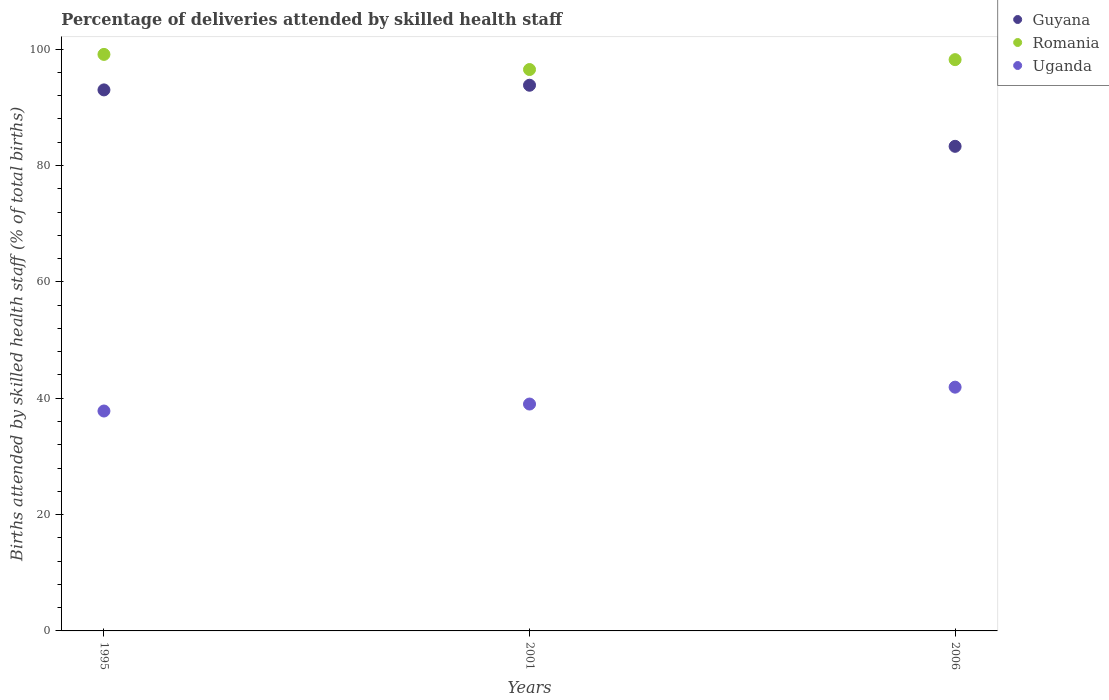How many different coloured dotlines are there?
Your answer should be very brief. 3. Across all years, what is the maximum percentage of births attended by skilled health staff in Guyana?
Ensure brevity in your answer.  93.8. Across all years, what is the minimum percentage of births attended by skilled health staff in Romania?
Keep it short and to the point. 96.5. What is the total percentage of births attended by skilled health staff in Guyana in the graph?
Your answer should be very brief. 270.1. What is the difference between the percentage of births attended by skilled health staff in Romania in 2001 and that in 2006?
Your answer should be compact. -1.7. What is the difference between the percentage of births attended by skilled health staff in Romania in 1995 and the percentage of births attended by skilled health staff in Guyana in 2001?
Offer a very short reply. 5.3. What is the average percentage of births attended by skilled health staff in Uganda per year?
Ensure brevity in your answer.  39.57. In the year 1995, what is the difference between the percentage of births attended by skilled health staff in Romania and percentage of births attended by skilled health staff in Guyana?
Your answer should be very brief. 6.1. In how many years, is the percentage of births attended by skilled health staff in Romania greater than 16 %?
Offer a very short reply. 3. What is the ratio of the percentage of births attended by skilled health staff in Romania in 1995 to that in 2001?
Keep it short and to the point. 1.03. Is the percentage of births attended by skilled health staff in Romania in 1995 less than that in 2001?
Provide a succinct answer. No. What is the difference between the highest and the second highest percentage of births attended by skilled health staff in Guyana?
Your response must be concise. 0.8. In how many years, is the percentage of births attended by skilled health staff in Guyana greater than the average percentage of births attended by skilled health staff in Guyana taken over all years?
Your answer should be compact. 2. Is the sum of the percentage of births attended by skilled health staff in Romania in 1995 and 2001 greater than the maximum percentage of births attended by skilled health staff in Uganda across all years?
Your answer should be compact. Yes. Does the percentage of births attended by skilled health staff in Romania monotonically increase over the years?
Give a very brief answer. No. How many dotlines are there?
Make the answer very short. 3. Are the values on the major ticks of Y-axis written in scientific E-notation?
Give a very brief answer. No. Does the graph contain any zero values?
Provide a short and direct response. No. Does the graph contain grids?
Provide a succinct answer. No. Where does the legend appear in the graph?
Your answer should be compact. Top right. How many legend labels are there?
Give a very brief answer. 3. What is the title of the graph?
Make the answer very short. Percentage of deliveries attended by skilled health staff. What is the label or title of the X-axis?
Keep it short and to the point. Years. What is the label or title of the Y-axis?
Make the answer very short. Births attended by skilled health staff (% of total births). What is the Births attended by skilled health staff (% of total births) of Guyana in 1995?
Give a very brief answer. 93. What is the Births attended by skilled health staff (% of total births) of Romania in 1995?
Your answer should be compact. 99.1. What is the Births attended by skilled health staff (% of total births) of Uganda in 1995?
Provide a short and direct response. 37.8. What is the Births attended by skilled health staff (% of total births) in Guyana in 2001?
Make the answer very short. 93.8. What is the Births attended by skilled health staff (% of total births) in Romania in 2001?
Provide a succinct answer. 96.5. What is the Births attended by skilled health staff (% of total births) in Uganda in 2001?
Offer a terse response. 39. What is the Births attended by skilled health staff (% of total births) in Guyana in 2006?
Offer a very short reply. 83.3. What is the Births attended by skilled health staff (% of total births) of Romania in 2006?
Keep it short and to the point. 98.2. What is the Births attended by skilled health staff (% of total births) of Uganda in 2006?
Offer a terse response. 41.9. Across all years, what is the maximum Births attended by skilled health staff (% of total births) of Guyana?
Provide a short and direct response. 93.8. Across all years, what is the maximum Births attended by skilled health staff (% of total births) of Romania?
Make the answer very short. 99.1. Across all years, what is the maximum Births attended by skilled health staff (% of total births) in Uganda?
Your answer should be very brief. 41.9. Across all years, what is the minimum Births attended by skilled health staff (% of total births) in Guyana?
Offer a terse response. 83.3. Across all years, what is the minimum Births attended by skilled health staff (% of total births) of Romania?
Provide a succinct answer. 96.5. Across all years, what is the minimum Births attended by skilled health staff (% of total births) in Uganda?
Offer a terse response. 37.8. What is the total Births attended by skilled health staff (% of total births) of Guyana in the graph?
Keep it short and to the point. 270.1. What is the total Births attended by skilled health staff (% of total births) in Romania in the graph?
Your answer should be compact. 293.8. What is the total Births attended by skilled health staff (% of total births) in Uganda in the graph?
Offer a terse response. 118.7. What is the difference between the Births attended by skilled health staff (% of total births) in Guyana in 1995 and that in 2001?
Offer a very short reply. -0.8. What is the difference between the Births attended by skilled health staff (% of total births) in Romania in 1995 and that in 2001?
Offer a terse response. 2.6. What is the difference between the Births attended by skilled health staff (% of total births) of Uganda in 1995 and that in 2001?
Provide a succinct answer. -1.2. What is the difference between the Births attended by skilled health staff (% of total births) of Romania in 1995 and that in 2006?
Provide a short and direct response. 0.9. What is the difference between the Births attended by skilled health staff (% of total births) of Uganda in 1995 and that in 2006?
Provide a succinct answer. -4.1. What is the difference between the Births attended by skilled health staff (% of total births) in Romania in 1995 and the Births attended by skilled health staff (% of total births) in Uganda in 2001?
Make the answer very short. 60.1. What is the difference between the Births attended by skilled health staff (% of total births) of Guyana in 1995 and the Births attended by skilled health staff (% of total births) of Romania in 2006?
Ensure brevity in your answer.  -5.2. What is the difference between the Births attended by skilled health staff (% of total births) of Guyana in 1995 and the Births attended by skilled health staff (% of total births) of Uganda in 2006?
Give a very brief answer. 51.1. What is the difference between the Births attended by skilled health staff (% of total births) of Romania in 1995 and the Births attended by skilled health staff (% of total births) of Uganda in 2006?
Provide a succinct answer. 57.2. What is the difference between the Births attended by skilled health staff (% of total births) of Guyana in 2001 and the Births attended by skilled health staff (% of total births) of Uganda in 2006?
Your response must be concise. 51.9. What is the difference between the Births attended by skilled health staff (% of total births) in Romania in 2001 and the Births attended by skilled health staff (% of total births) in Uganda in 2006?
Keep it short and to the point. 54.6. What is the average Births attended by skilled health staff (% of total births) in Guyana per year?
Offer a terse response. 90.03. What is the average Births attended by skilled health staff (% of total births) of Romania per year?
Your answer should be very brief. 97.93. What is the average Births attended by skilled health staff (% of total births) in Uganda per year?
Provide a short and direct response. 39.57. In the year 1995, what is the difference between the Births attended by skilled health staff (% of total births) of Guyana and Births attended by skilled health staff (% of total births) of Uganda?
Ensure brevity in your answer.  55.2. In the year 1995, what is the difference between the Births attended by skilled health staff (% of total births) in Romania and Births attended by skilled health staff (% of total births) in Uganda?
Offer a terse response. 61.3. In the year 2001, what is the difference between the Births attended by skilled health staff (% of total births) in Guyana and Births attended by skilled health staff (% of total births) in Uganda?
Offer a terse response. 54.8. In the year 2001, what is the difference between the Births attended by skilled health staff (% of total births) of Romania and Births attended by skilled health staff (% of total births) of Uganda?
Ensure brevity in your answer.  57.5. In the year 2006, what is the difference between the Births attended by skilled health staff (% of total births) in Guyana and Births attended by skilled health staff (% of total births) in Romania?
Offer a terse response. -14.9. In the year 2006, what is the difference between the Births attended by skilled health staff (% of total births) in Guyana and Births attended by skilled health staff (% of total births) in Uganda?
Offer a terse response. 41.4. In the year 2006, what is the difference between the Births attended by skilled health staff (% of total births) in Romania and Births attended by skilled health staff (% of total births) in Uganda?
Offer a very short reply. 56.3. What is the ratio of the Births attended by skilled health staff (% of total births) of Guyana in 1995 to that in 2001?
Your answer should be compact. 0.99. What is the ratio of the Births attended by skilled health staff (% of total births) in Romania in 1995 to that in 2001?
Offer a terse response. 1.03. What is the ratio of the Births attended by skilled health staff (% of total births) of Uganda in 1995 to that in 2001?
Give a very brief answer. 0.97. What is the ratio of the Births attended by skilled health staff (% of total births) of Guyana in 1995 to that in 2006?
Ensure brevity in your answer.  1.12. What is the ratio of the Births attended by skilled health staff (% of total births) of Romania in 1995 to that in 2006?
Your answer should be very brief. 1.01. What is the ratio of the Births attended by skilled health staff (% of total births) in Uganda in 1995 to that in 2006?
Provide a short and direct response. 0.9. What is the ratio of the Births attended by skilled health staff (% of total births) of Guyana in 2001 to that in 2006?
Keep it short and to the point. 1.13. What is the ratio of the Births attended by skilled health staff (% of total births) of Romania in 2001 to that in 2006?
Offer a terse response. 0.98. What is the ratio of the Births attended by skilled health staff (% of total births) in Uganda in 2001 to that in 2006?
Keep it short and to the point. 0.93. What is the difference between the highest and the second highest Births attended by skilled health staff (% of total births) of Guyana?
Your response must be concise. 0.8. What is the difference between the highest and the second highest Births attended by skilled health staff (% of total births) in Romania?
Keep it short and to the point. 0.9. What is the difference between the highest and the second highest Births attended by skilled health staff (% of total births) in Uganda?
Offer a very short reply. 2.9. What is the difference between the highest and the lowest Births attended by skilled health staff (% of total births) in Romania?
Your response must be concise. 2.6. 